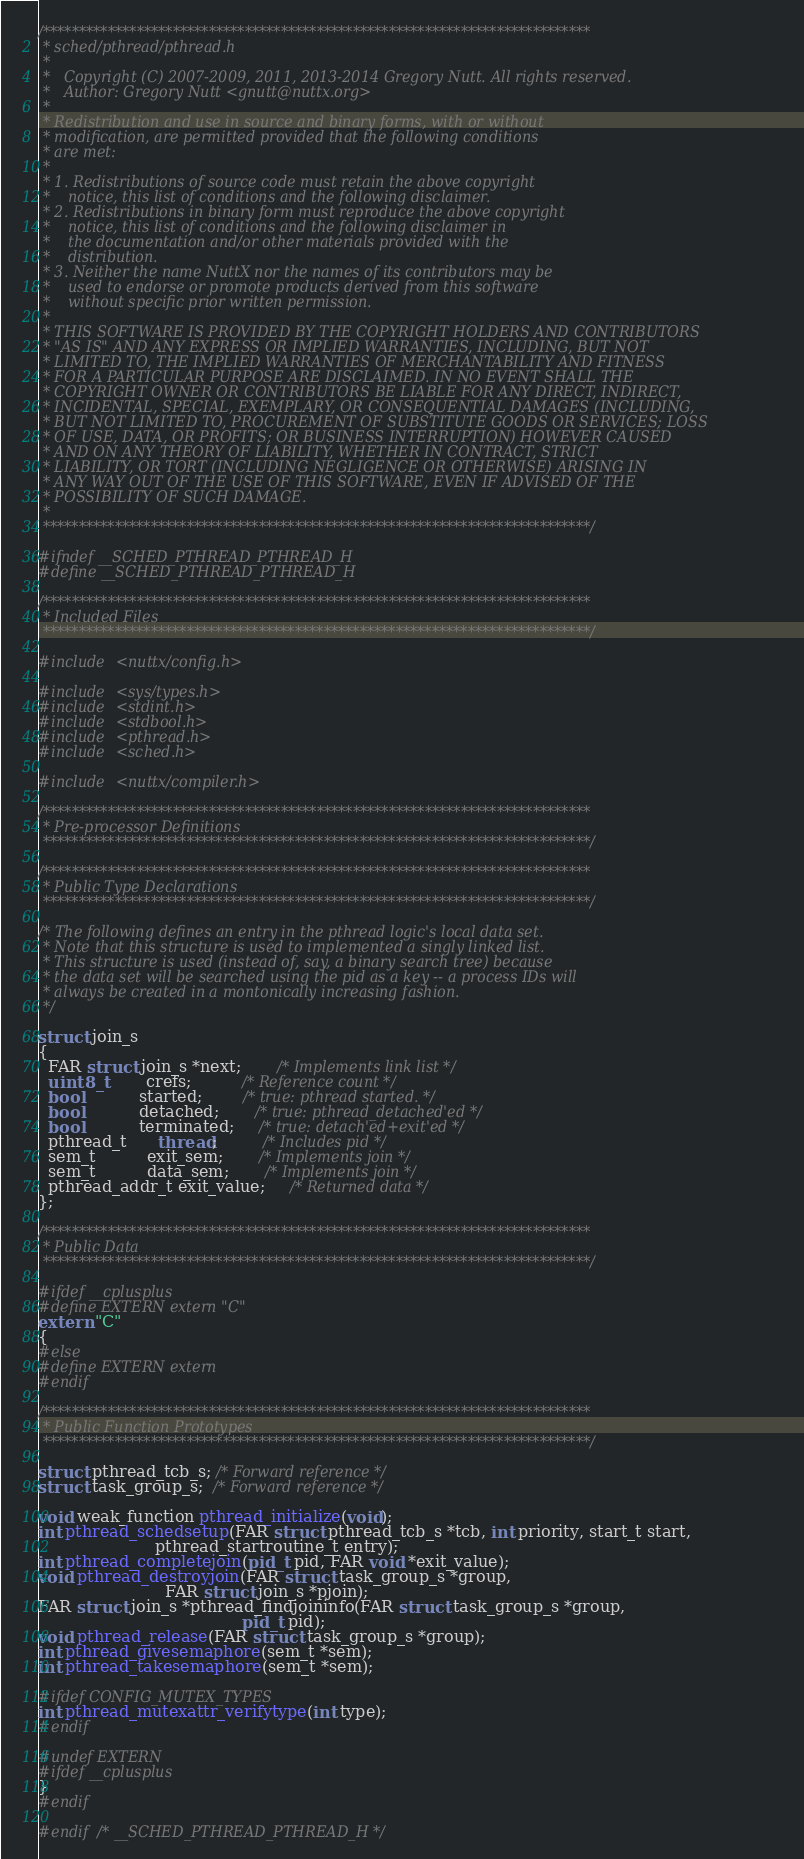Convert code to text. <code><loc_0><loc_0><loc_500><loc_500><_C_>/****************************************************************************
 * sched/pthread/pthread.h
 *
 *   Copyright (C) 2007-2009, 2011, 2013-2014 Gregory Nutt. All rights reserved.
 *   Author: Gregory Nutt <gnutt@nuttx.org>
 *
 * Redistribution and use in source and binary forms, with or without
 * modification, are permitted provided that the following conditions
 * are met:
 *
 * 1. Redistributions of source code must retain the above copyright
 *    notice, this list of conditions and the following disclaimer.
 * 2. Redistributions in binary form must reproduce the above copyright
 *    notice, this list of conditions and the following disclaimer in
 *    the documentation and/or other materials provided with the
 *    distribution.
 * 3. Neither the name NuttX nor the names of its contributors may be
 *    used to endorse or promote products derived from this software
 *    without specific prior written permission.
 *
 * THIS SOFTWARE IS PROVIDED BY THE COPYRIGHT HOLDERS AND CONTRIBUTORS
 * "AS IS" AND ANY EXPRESS OR IMPLIED WARRANTIES, INCLUDING, BUT NOT
 * LIMITED TO, THE IMPLIED WARRANTIES OF MERCHANTABILITY AND FITNESS
 * FOR A PARTICULAR PURPOSE ARE DISCLAIMED. IN NO EVENT SHALL THE
 * COPYRIGHT OWNER OR CONTRIBUTORS BE LIABLE FOR ANY DIRECT, INDIRECT,
 * INCIDENTAL, SPECIAL, EXEMPLARY, OR CONSEQUENTIAL DAMAGES (INCLUDING,
 * BUT NOT LIMITED TO, PROCUREMENT OF SUBSTITUTE GOODS OR SERVICES; LOSS
 * OF USE, DATA, OR PROFITS; OR BUSINESS INTERRUPTION) HOWEVER CAUSED
 * AND ON ANY THEORY OF LIABILITY, WHETHER IN CONTRACT, STRICT
 * LIABILITY, OR TORT (INCLUDING NEGLIGENCE OR OTHERWISE) ARISING IN
 * ANY WAY OUT OF THE USE OF THIS SOFTWARE, EVEN IF ADVISED OF THE
 * POSSIBILITY OF SUCH DAMAGE.
 *
 ****************************************************************************/

#ifndef __SCHED_PTHREAD_PTHREAD_H
#define __SCHED_PTHREAD_PTHREAD_H

/****************************************************************************
 * Included Files
 ****************************************************************************/

#include <nuttx/config.h>

#include <sys/types.h>
#include <stdint.h>
#include <stdbool.h>
#include <pthread.h>
#include <sched.h>

#include <nuttx/compiler.h>

/****************************************************************************
 * Pre-processor Definitions
 ****************************************************************************/

/****************************************************************************
 * Public Type Declarations
 ****************************************************************************/

/* The following defines an entry in the pthread logic's local data set.
 * Note that this structure is used to implemented a singly linked list.
 * This structure is used (instead of, say, a binary search tree) because
 * the data set will be searched using the pid as a key -- a process IDs will
 * always be created in a montonically increasing fashion.
 */

struct join_s
{
  FAR struct join_s *next;       /* Implements link list */
  uint8_t        crefs;          /* Reference count */
  bool           started;        /* true: pthread started. */
  bool           detached;       /* true: pthread_detached'ed */
  bool           terminated;     /* true: detach'ed+exit'ed */
  pthread_t      thread;         /* Includes pid */
  sem_t          exit_sem;       /* Implements join */
  sem_t          data_sem;       /* Implements join */
  pthread_addr_t exit_value;     /* Returned data */
};

/****************************************************************************
 * Public Data
 ****************************************************************************/

#ifdef __cplusplus
#define EXTERN extern "C"
extern "C"
{
#else
#define EXTERN extern
#endif

/****************************************************************************
 * Public Function Prototypes
 ****************************************************************************/

struct pthread_tcb_s; /* Forward reference */
struct task_group_s;  /* Forward reference */

void weak_function pthread_initialize(void);
int pthread_schedsetup(FAR struct pthread_tcb_s *tcb, int priority, start_t start,
                       pthread_startroutine_t entry);
int pthread_completejoin(pid_t pid, FAR void *exit_value);
void pthread_destroyjoin(FAR struct task_group_s *group,
                         FAR struct join_s *pjoin);
FAR struct join_s *pthread_findjoininfo(FAR struct task_group_s *group,
                                        pid_t pid);
void pthread_release(FAR struct task_group_s *group);
int pthread_givesemaphore(sem_t *sem);
int pthread_takesemaphore(sem_t *sem);

#ifdef CONFIG_MUTEX_TYPES
int pthread_mutexattr_verifytype(int type);
#endif

#undef EXTERN
#ifdef __cplusplus
}
#endif

#endif /* __SCHED_PTHREAD_PTHREAD_H */

</code> 